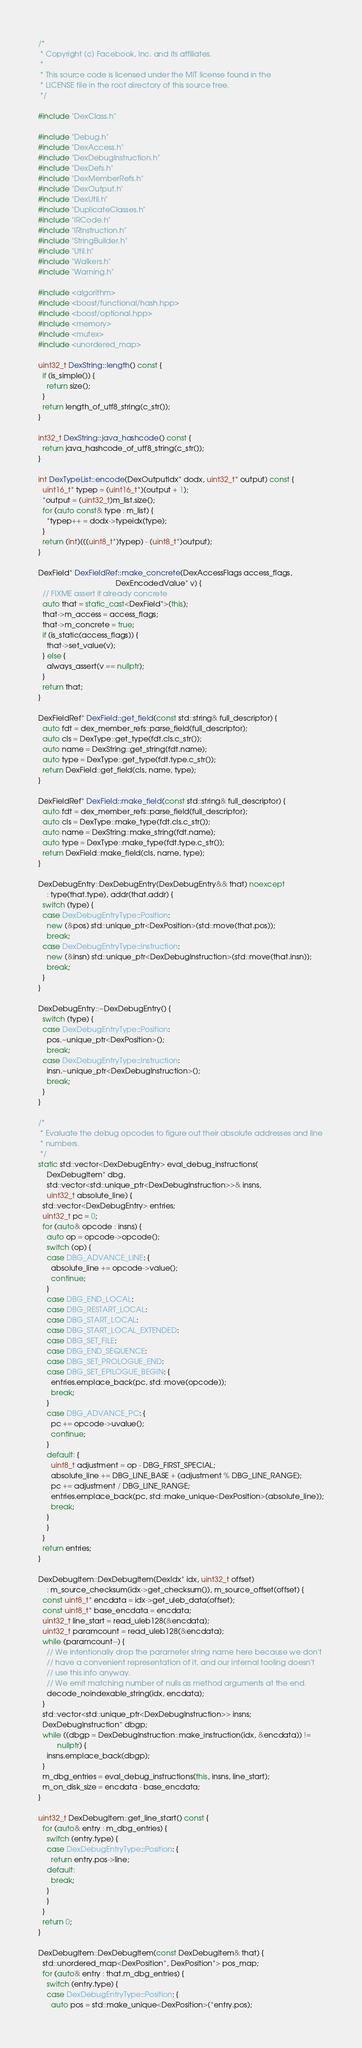<code> <loc_0><loc_0><loc_500><loc_500><_C++_>/*
 * Copyright (c) Facebook, Inc. and its affiliates.
 *
 * This source code is licensed under the MIT license found in the
 * LICENSE file in the root directory of this source tree.
 */

#include "DexClass.h"

#include "Debug.h"
#include "DexAccess.h"
#include "DexDebugInstruction.h"
#include "DexDefs.h"
#include "DexMemberRefs.h"
#include "DexOutput.h"
#include "DexUtil.h"
#include "DuplicateClasses.h"
#include "IRCode.h"
#include "IRInstruction.h"
#include "StringBuilder.h"
#include "Util.h"
#include "Walkers.h"
#include "Warning.h"

#include <algorithm>
#include <boost/functional/hash.hpp>
#include <boost/optional.hpp>
#include <memory>
#include <mutex>
#include <unordered_map>

uint32_t DexString::length() const {
  if (is_simple()) {
    return size();
  }
  return length_of_utf8_string(c_str());
}

int32_t DexString::java_hashcode() const {
  return java_hashcode_of_utf8_string(c_str());
}

int DexTypeList::encode(DexOutputIdx* dodx, uint32_t* output) const {
  uint16_t* typep = (uint16_t*)(output + 1);
  *output = (uint32_t)m_list.size();
  for (auto const& type : m_list) {
    *typep++ = dodx->typeidx(type);
  }
  return (int)(((uint8_t*)typep) - (uint8_t*)output);
}

DexField* DexFieldRef::make_concrete(DexAccessFlags access_flags,
                                     DexEncodedValue* v) {
  // FIXME assert if already concrete
  auto that = static_cast<DexField*>(this);
  that->m_access = access_flags;
  that->m_concrete = true;
  if (is_static(access_flags)) {
    that->set_value(v);
  } else {
    always_assert(v == nullptr);
  }
  return that;
}

DexFieldRef* DexField::get_field(const std::string& full_descriptor) {
  auto fdt = dex_member_refs::parse_field(full_descriptor);
  auto cls = DexType::get_type(fdt.cls.c_str());
  auto name = DexString::get_string(fdt.name);
  auto type = DexType::get_type(fdt.type.c_str());
  return DexField::get_field(cls, name, type);
}

DexFieldRef* DexField::make_field(const std::string& full_descriptor) {
  auto fdt = dex_member_refs::parse_field(full_descriptor);
  auto cls = DexType::make_type(fdt.cls.c_str());
  auto name = DexString::make_string(fdt.name);
  auto type = DexType::make_type(fdt.type.c_str());
  return DexField::make_field(cls, name, type);
}

DexDebugEntry::DexDebugEntry(DexDebugEntry&& that) noexcept
    : type(that.type), addr(that.addr) {
  switch (type) {
  case DexDebugEntryType::Position:
    new (&pos) std::unique_ptr<DexPosition>(std::move(that.pos));
    break;
  case DexDebugEntryType::Instruction:
    new (&insn) std::unique_ptr<DexDebugInstruction>(std::move(that.insn));
    break;
  }
}

DexDebugEntry::~DexDebugEntry() {
  switch (type) {
  case DexDebugEntryType::Position:
    pos.~unique_ptr<DexPosition>();
    break;
  case DexDebugEntryType::Instruction:
    insn.~unique_ptr<DexDebugInstruction>();
    break;
  }
}

/*
 * Evaluate the debug opcodes to figure out their absolute addresses and line
 * numbers.
 */
static std::vector<DexDebugEntry> eval_debug_instructions(
    DexDebugItem* dbg,
    std::vector<std::unique_ptr<DexDebugInstruction>>& insns,
    uint32_t absolute_line) {
  std::vector<DexDebugEntry> entries;
  uint32_t pc = 0;
  for (auto& opcode : insns) {
    auto op = opcode->opcode();
    switch (op) {
    case DBG_ADVANCE_LINE: {
      absolute_line += opcode->value();
      continue;
    }
    case DBG_END_LOCAL:
    case DBG_RESTART_LOCAL:
    case DBG_START_LOCAL:
    case DBG_START_LOCAL_EXTENDED:
    case DBG_SET_FILE:
    case DBG_END_SEQUENCE:
    case DBG_SET_PROLOGUE_END:
    case DBG_SET_EPILOGUE_BEGIN: {
      entries.emplace_back(pc, std::move(opcode));
      break;
    }
    case DBG_ADVANCE_PC: {
      pc += opcode->uvalue();
      continue;
    }
    default: {
      uint8_t adjustment = op - DBG_FIRST_SPECIAL;
      absolute_line += DBG_LINE_BASE + (adjustment % DBG_LINE_RANGE);
      pc += adjustment / DBG_LINE_RANGE;
      entries.emplace_back(pc, std::make_unique<DexPosition>(absolute_line));
      break;
    }
    }
  }
  return entries;
}

DexDebugItem::DexDebugItem(DexIdx* idx, uint32_t offset)
    : m_source_checksum(idx->get_checksum()), m_source_offset(offset) {
  const uint8_t* encdata = idx->get_uleb_data(offset);
  const uint8_t* base_encdata = encdata;
  uint32_t line_start = read_uleb128(&encdata);
  uint32_t paramcount = read_uleb128(&encdata);
  while (paramcount--) {
    // We intentionally drop the parameter string name here because we don't
    // have a convenient representation of it, and our internal tooling doesn't
    // use this info anyway.
    // We emit matching number of nulls as method arguments at the end.
    decode_noindexable_string(idx, encdata);
  }
  std::vector<std::unique_ptr<DexDebugInstruction>> insns;
  DexDebugInstruction* dbgp;
  while ((dbgp = DexDebugInstruction::make_instruction(idx, &encdata)) !=
         nullptr) {
    insns.emplace_back(dbgp);
  }
  m_dbg_entries = eval_debug_instructions(this, insns, line_start);
  m_on_disk_size = encdata - base_encdata;
}

uint32_t DexDebugItem::get_line_start() const {
  for (auto& entry : m_dbg_entries) {
    switch (entry.type) {
    case DexDebugEntryType::Position: {
      return entry.pos->line;
    default:
      break;
    }
    }
  }
  return 0;
}

DexDebugItem::DexDebugItem(const DexDebugItem& that) {
  std::unordered_map<DexPosition*, DexPosition*> pos_map;
  for (auto& entry : that.m_dbg_entries) {
    switch (entry.type) {
    case DexDebugEntryType::Position: {
      auto pos = std::make_unique<DexPosition>(*entry.pos);</code> 